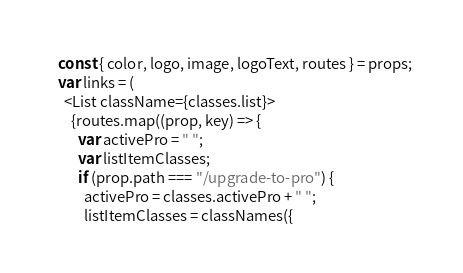Convert code to text. <code><loc_0><loc_0><loc_500><loc_500><_JavaScript_>  const { color, logo, image, logoText, routes } = props;
  var links = (
    <List className={classes.list}>
      {routes.map((prop, key) => {
        var activePro = " ";
        var listItemClasses;
        if (prop.path === "/upgrade-to-pro") {
          activePro = classes.activePro + " ";
          listItemClasses = classNames({</code> 